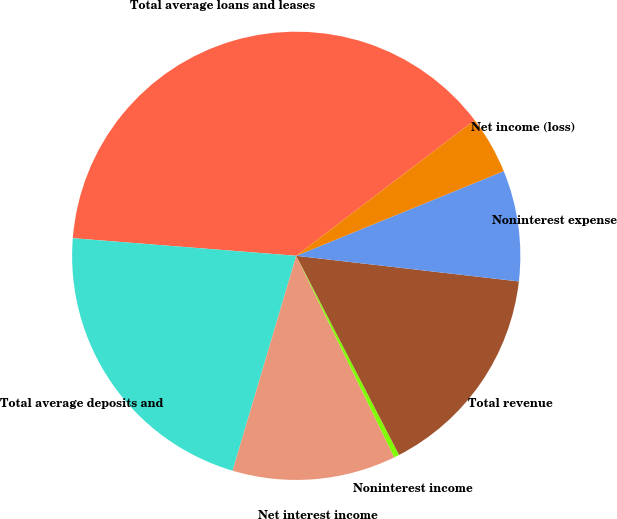Convert chart. <chart><loc_0><loc_0><loc_500><loc_500><pie_chart><fcel>Total average loans and leases<fcel>Total average deposits and<fcel>Net interest income<fcel>Noninterest income<fcel>Total revenue<fcel>Noninterest expense<fcel>Net income (loss)<nl><fcel>38.4%<fcel>21.67%<fcel>11.79%<fcel>0.38%<fcel>15.59%<fcel>7.99%<fcel>4.18%<nl></chart> 